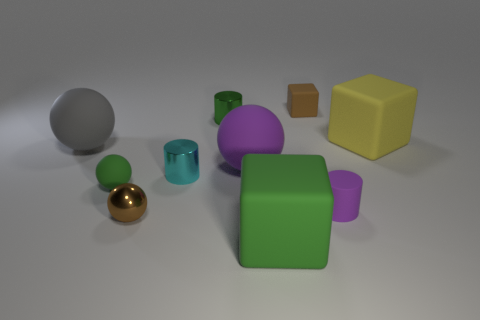Can you describe the different materials that the objects in the image may represent, starting with the large yellow cube? The large yellow cube appears smooth and shiny, suggesting a plastic material. The reflective qualities and consistent color give it an artificial, possibly acrylic look, commonly associated with plastic items. What about the silver sphere? The silver sphere's reflective surface and metallic sheen could indicate that it is meant to represent a polished metal, perhaps steel or aluminum, known for their lustrous and reflective properties. 